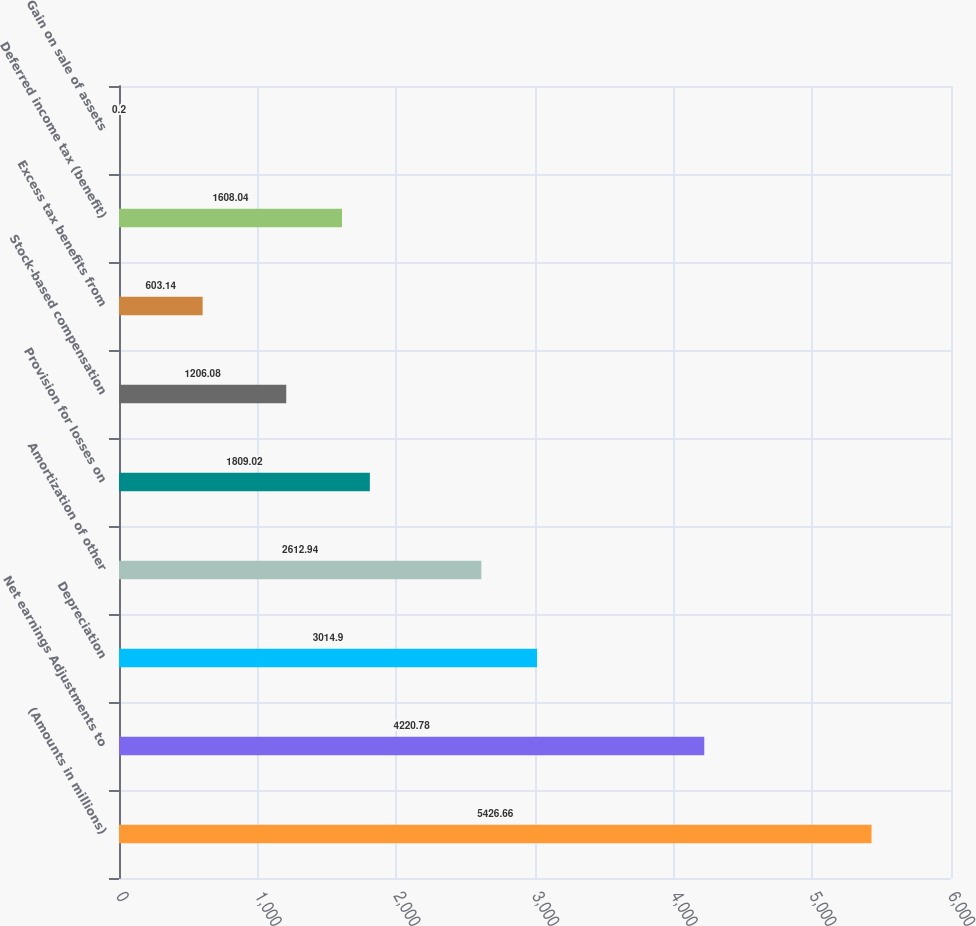Convert chart. <chart><loc_0><loc_0><loc_500><loc_500><bar_chart><fcel>(Amounts in millions)<fcel>Net earnings Adjustments to<fcel>Depreciation<fcel>Amortization of other<fcel>Provision for losses on<fcel>Stock-based compensation<fcel>Excess tax benefits from<fcel>Deferred income tax (benefit)<fcel>Gain on sale of assets<nl><fcel>5426.66<fcel>4220.78<fcel>3014.9<fcel>2612.94<fcel>1809.02<fcel>1206.08<fcel>603.14<fcel>1608.04<fcel>0.2<nl></chart> 